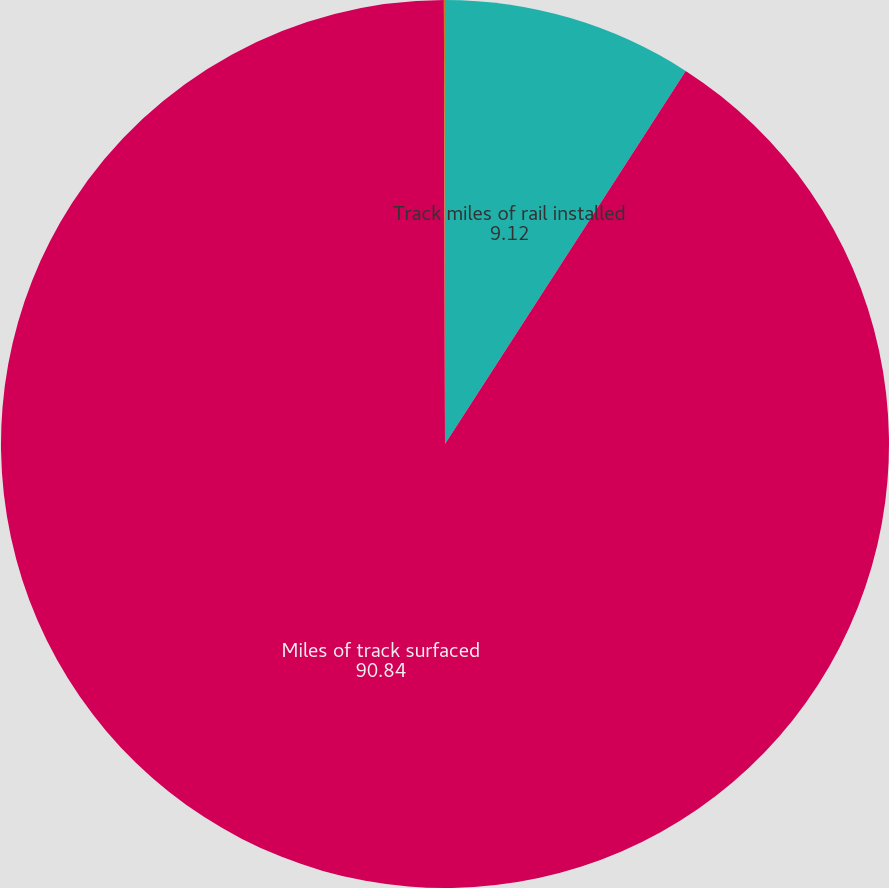<chart> <loc_0><loc_0><loc_500><loc_500><pie_chart><fcel>Track miles of rail installed<fcel>Miles of track surfaced<fcel>New crossties installed<nl><fcel>9.12%<fcel>90.84%<fcel>0.04%<nl></chart> 